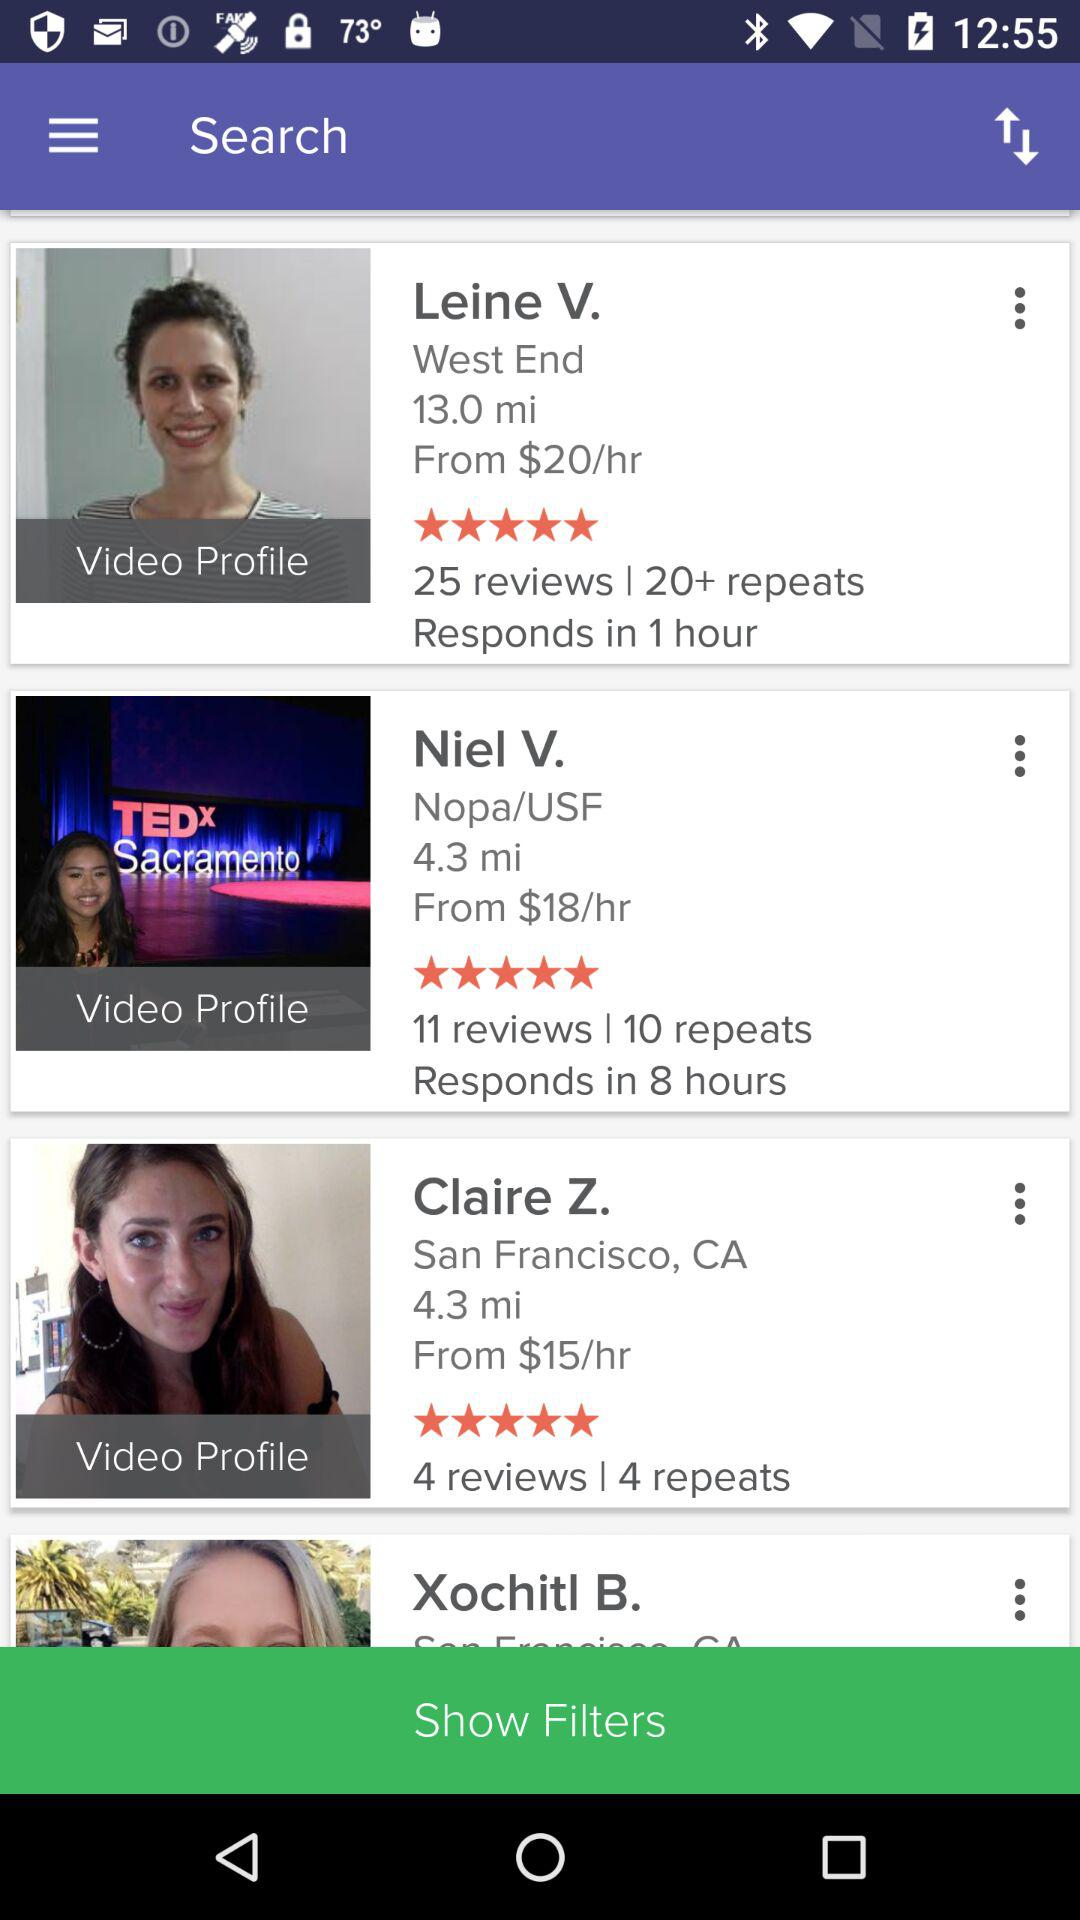What is Leine V.'s star rating? Leine V.'s star rating is 5 stars. 